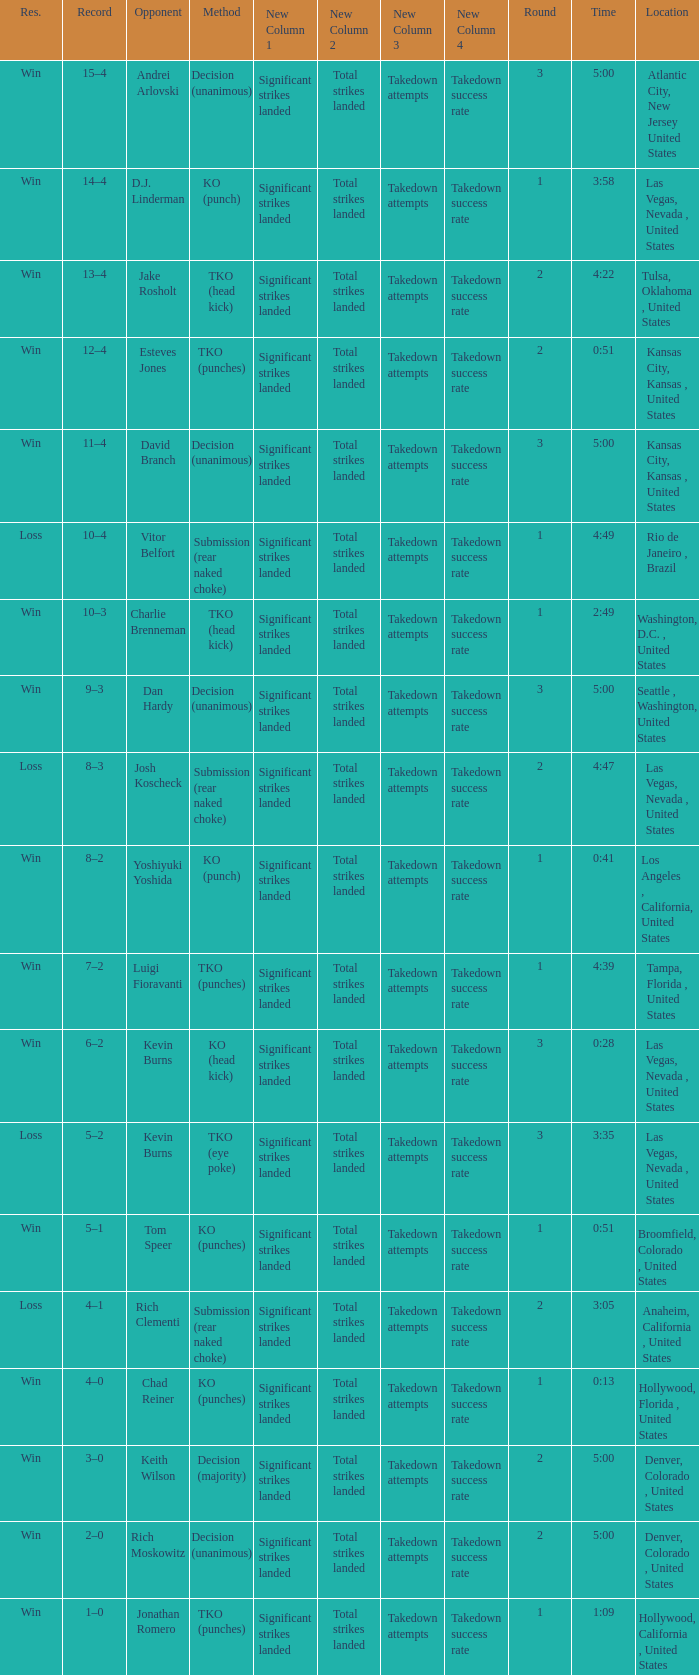Which record has a time of 0:13? 4–0. 